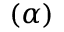<formula> <loc_0><loc_0><loc_500><loc_500>( \alpha )</formula> 